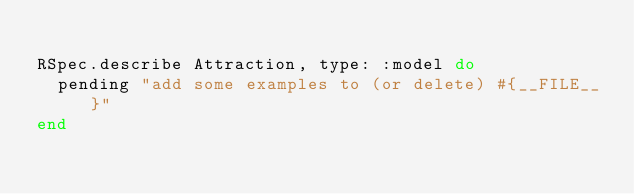<code> <loc_0><loc_0><loc_500><loc_500><_Ruby_>
RSpec.describe Attraction, type: :model do
  pending "add some examples to (or delete) #{__FILE__}"
end
</code> 